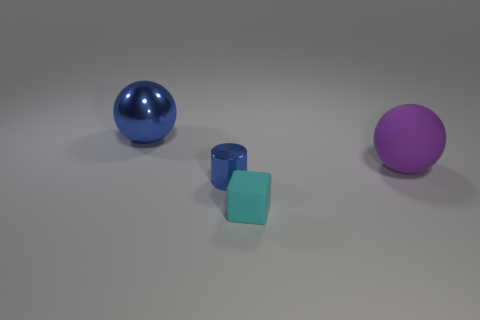Add 2 big purple matte objects. How many objects exist? 6 Subtract all cubes. How many objects are left? 3 Subtract all tiny cyan matte spheres. Subtract all balls. How many objects are left? 2 Add 4 large blue things. How many large blue things are left? 5 Add 3 big purple cubes. How many big purple cubes exist? 3 Subtract 0 green blocks. How many objects are left? 4 